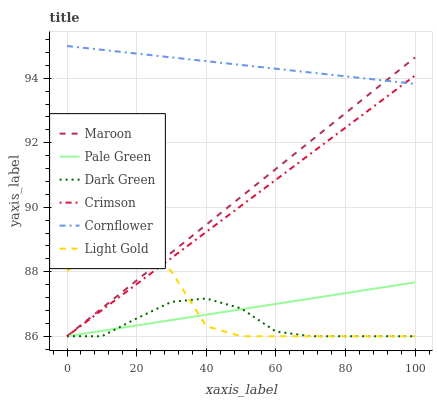Does Dark Green have the minimum area under the curve?
Answer yes or no. Yes. Does Cornflower have the maximum area under the curve?
Answer yes or no. Yes. Does Maroon have the minimum area under the curve?
Answer yes or no. No. Does Maroon have the maximum area under the curve?
Answer yes or no. No. Is Maroon the smoothest?
Answer yes or no. Yes. Is Light Gold the roughest?
Answer yes or no. Yes. Is Pale Green the smoothest?
Answer yes or no. No. Is Pale Green the roughest?
Answer yes or no. No. Does Maroon have the lowest value?
Answer yes or no. Yes. Does Cornflower have the highest value?
Answer yes or no. Yes. Does Maroon have the highest value?
Answer yes or no. No. Is Light Gold less than Cornflower?
Answer yes or no. Yes. Is Cornflower greater than Pale Green?
Answer yes or no. Yes. Does Crimson intersect Cornflower?
Answer yes or no. Yes. Is Crimson less than Cornflower?
Answer yes or no. No. Is Crimson greater than Cornflower?
Answer yes or no. No. Does Light Gold intersect Cornflower?
Answer yes or no. No. 